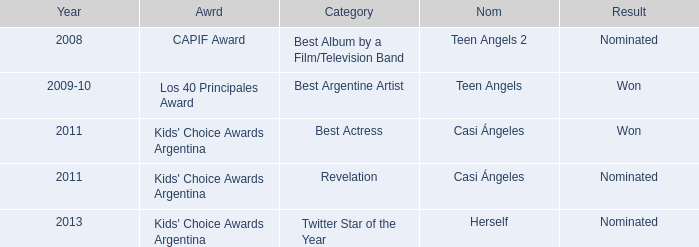For what award was there a nomination for Best Actress? Kids' Choice Awards Argentina. 